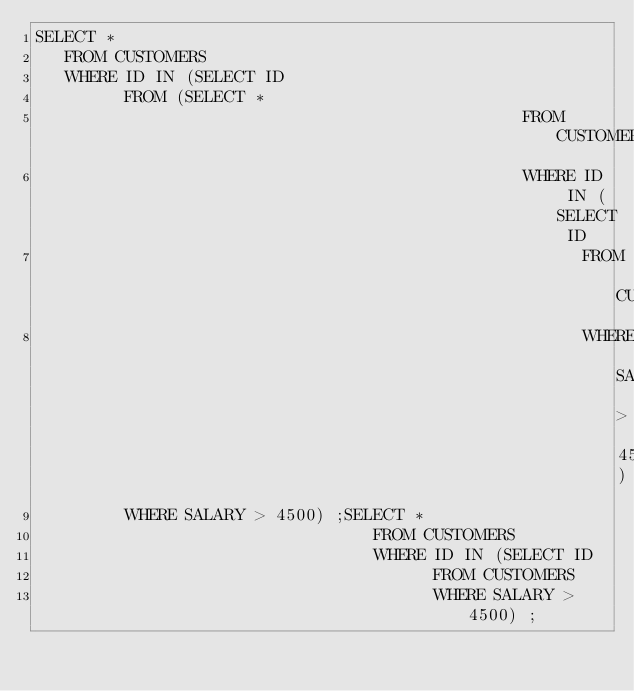Convert code to text. <code><loc_0><loc_0><loc_500><loc_500><_SQL_>SELECT *
   FROM CUSTOMERS
   WHERE ID IN (SELECT ID
         FROM (SELECT *
                                                 FROM CUSTOMERS
                                                 WHERE ID IN (SELECT ID
                                                       FROM CUSTOMERS
                                                       WHERE SALARY > 4500))
         WHERE SALARY > 4500) ;SELECT *
                                  FROM CUSTOMERS
                                  WHERE ID IN (SELECT ID
                                        FROM CUSTOMERS
                                        WHERE SALARY > 4500) ;</code> 